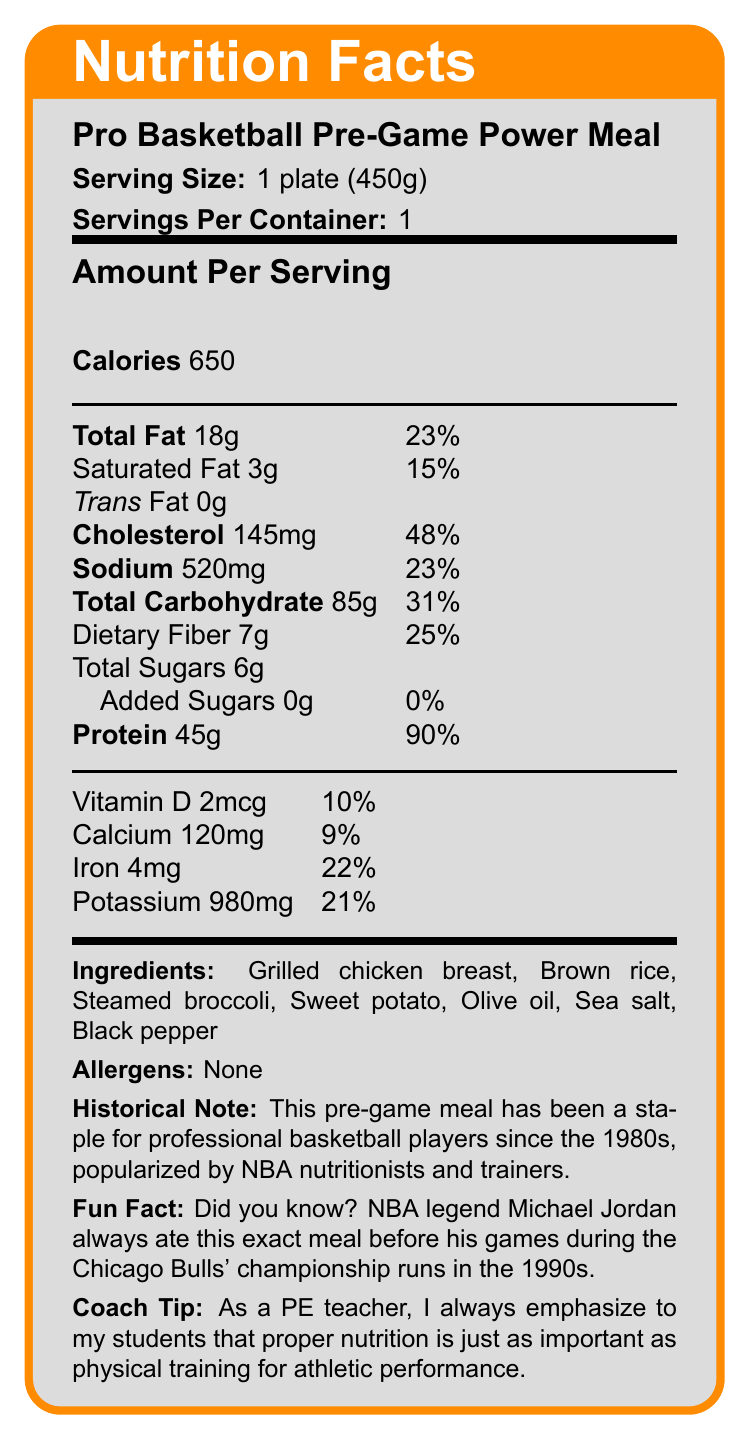what is the serving size of the Pro Basketball Pre-Game Power Meal? The document specifies the serving size as 1 plate (450g).
Answer: 1 plate (450g) how many calories are in one serving of the Pro Basketball Pre-Game Power Meal? The document lists the calories per serving as 650.
Answer: 650 how many grams of dietary fiber are in the meal? The nutrition facts label shows 7g of dietary fiber in the meal.
Answer: 7g what is the percentage of daily value for protein in this meal? The document specifies that the protein content in one serving is 45g, which is equivalent to 90% of the daily value.
Answer: 90% which ingredient in the meal is a vegetable? Among the listed ingredients, steamed broccoli is a vegetable.
Answer: Steamed broccoli what is the amount of cholesterol in the meal? The document states that the cholesterol content is 145mg per serving.
Answer: 145mg which of the following is NOT an ingredient in the Pro Basketball Pre-Game Power Meal? A. Grilled chicken breast B. Brown rice C. Pasta D. Sweet potato The listed ingredients do not include pasta.
Answer: C. Pasta what year range is mentioned in the fun fact? A. 1980s B. 1990s C. 2000s D. 2010s The fun fact mentions the 1990s, specifically referencing Michael Jordan's diet during the Chicago Bulls' championship runs.
Answer: B. 1990s is the Pro Basketball Pre-Game Power Meal free from added sugars? The document specifies that there are 0g of added sugars in the meal.
Answer: Yes summarize the main idea of the document. The document provides comprehensive information on the nutritional value of the pre-game meal, its ingredients, historical significance, and a fun fact, emphasizing the importance of nutrition in athletic performance.
Answer: The document is a nutrition label for a Pro Basketball Pre-Game Power Meal, detailing serving size, calorie content, nutritional information, ingredients, allergens, historical note, fun fact, and coach tip. what type of oil is used in the meal? The document lists olive oil as one of the ingredients.
Answer: Olive oil what is the fun fact related to the Pro Basketball Pre-Game Power Meal? The fun fact mentions Michael Jordan's pre-game routine involving this meal during the 1990s championship runs.
Answer: NBA legend Michael Jordan always ate this meal before his games during the Chicago Bulls' championship runs in the 1990s. how much potassium is in one serving of the meal? The document specifies that there is 980mg of potassium per serving.
Answer: 980mg what percentage of the daily value does sodium represent in the meal? According to the document, the sodium content is 520mg, representing 23% of the daily value.
Answer: 23% are there any allergens mentioned in the meal? The document states "None" under allergens, indicating there are no allergens present.
Answer: No what historical note is provided about the Pro Basketball Pre-Game Power Meal? The historical note mentions the meal's popularity among professional basketball players since the 1980s, thanks to NBA nutritionists and trainers.
Answer: This pre-game meal has been a staple for professional basketball players since the 1980s, popularized by NBA nutritionists and trainers. what is the amount of saturated fat in the meal? The document lists the saturated fat content as 3g per serving.
Answer: 3g does the nutrition label list the total sugars in the meal? The document lists the total sugars content as 6g per serving.
Answer: Yes what is the source of protein in the meal? Based on the ingredients list, the grilled chicken breast is the primary source of protein.
Answer: Grilled chicken breast what is the total carbohydrate content in this meal? The document specifies the total carbohydrate content as 85g per serving.
Answer: 85g how many servings are in the container? The document states that there is 1 serving per container.
Answer: 1 how much calcium is in the meal? The document lists the calcium content as 120mg per serving.
Answer: 120mg what is the daily value percentage of iron in the meal? The document specifies the iron content as 4mg, which is 22% of the daily value.
Answer: 22% is this meal high in trans fat? The document indicates that the trans fat content is 0g.
Answer: No does the document mention what sort of training the Pro Basketball Pre-Game Power Meal is designed to support? The document implies this through historical notes and the coach tip emphasizing proper nutrition for athletic performance.
Answer: Sports training, specifically for professional basketball players which NBA legend is associated with this meal during championship runs? The fun fact in the document mentions Michael Jordan as eating this meal during the Chicago Bulls' championship runs in the 1990s.
Answer: Michael Jordan how much vitamin D does the meal provide? The document lists the vitamin D content as 2mcg per serving.
Answer: 2mcg Can you find out the ingredient quantities in the meal? The document lists the ingredients but does not provide specific quantities of each ingredient.
Answer: Cannot be determined 